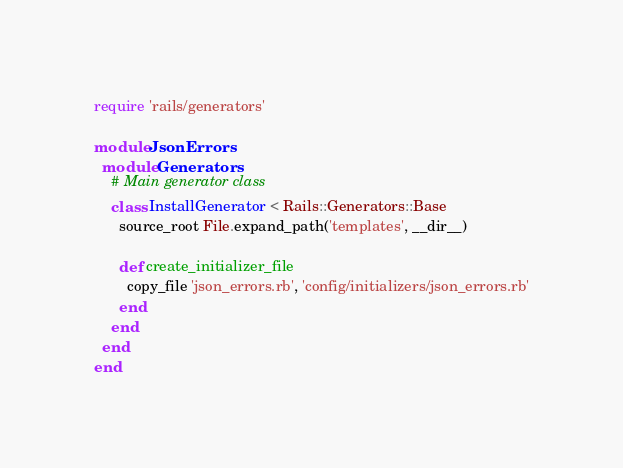<code> <loc_0><loc_0><loc_500><loc_500><_Ruby_>
require 'rails/generators'

module JsonErrors
  module Generators
    # Main generator class
    class InstallGenerator < Rails::Generators::Base
      source_root File.expand_path('templates', __dir__)

      def create_initializer_file
        copy_file 'json_errors.rb', 'config/initializers/json_errors.rb'
      end
    end
  end
end
</code> 